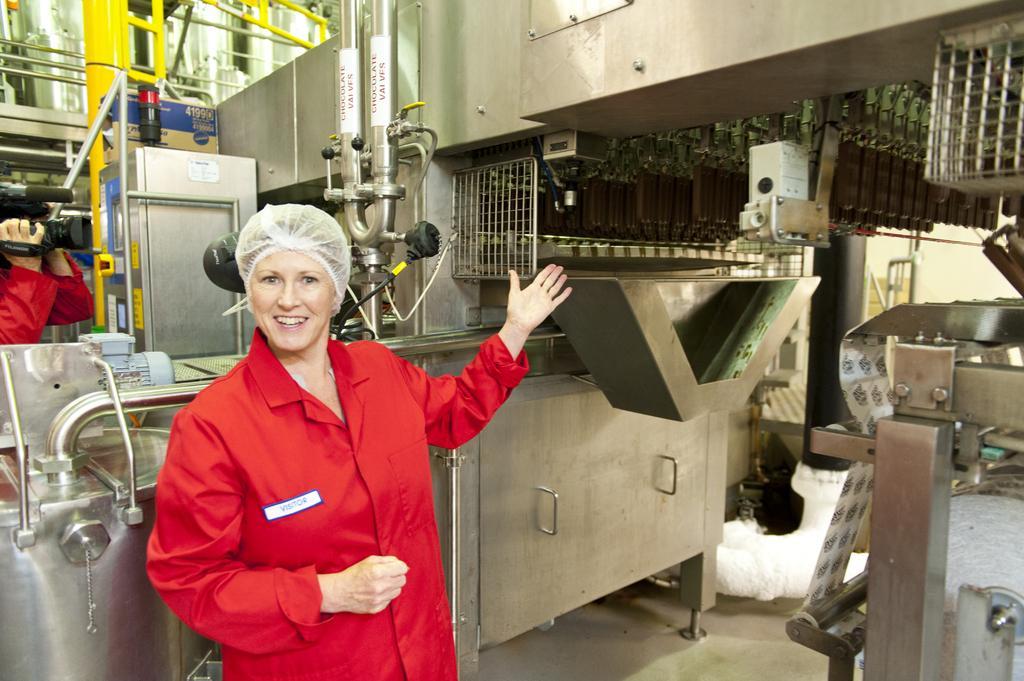Please provide a concise description of this image. In this image I can see on the left side a person is holding the camera, in the middle a woman is smiling by showing her hand, she is wearing red color coat. At the back side there are machines. 